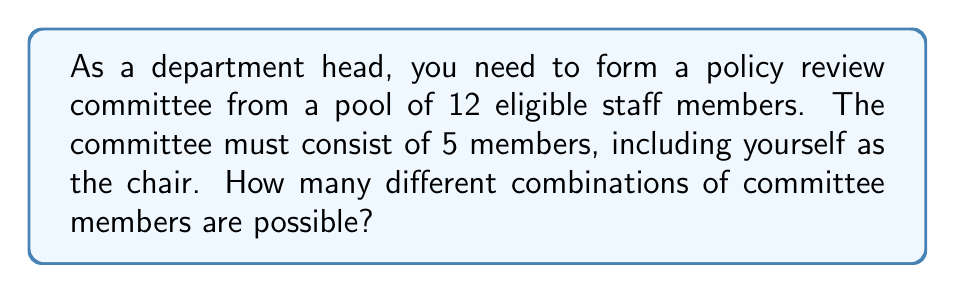Can you answer this question? To solve this problem, we need to use the combination formula. Here's a step-by-step explanation:

1. We start with 12 eligible staff members.
2. The committee needs 5 members in total.
3. You, as the department head, are automatically included as the chair.
4. This means we need to select 4 more members from the remaining 11 staff members.

We can use the combination formula:

$${n \choose r} = \frac{n!}{r!(n-r)!}$$

Where:
$n$ = total number of items to choose from
$r$ = number of items being chosen

In this case:
$n = 11$ (remaining staff members after excluding you)
$r = 4$ (additional members needed)

Plugging these values into the formula:

$${11 \choose 4} = \frac{11!}{4!(11-4)!} = \frac{11!}{4!7!}$$

Calculating this:

$$\frac{11 * 10 * 9 * 8 * 7!}{(4 * 3 * 2 * 1) * 7!}$$

The 7! cancels out in the numerator and denominator:

$$\frac{11 * 10 * 9 * 8}{4 * 3 * 2 * 1} = \frac{7920}{24} = 330$$

Therefore, there are 330 possible combinations for the committee.
Answer: 330 combinations 